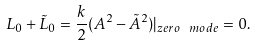Convert formula to latex. <formula><loc_0><loc_0><loc_500><loc_500>L _ { 0 } + \tilde { L } _ { 0 } = \frac { k } { 2 } ( A ^ { 2 } - \tilde { A } ^ { 2 } ) | _ { z e r o \ m o d e } = 0 .</formula> 